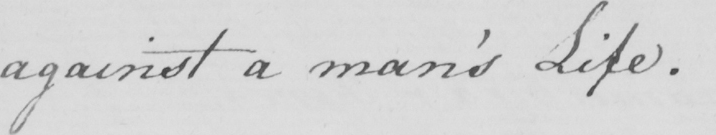What text is written in this handwritten line? against a man ' s Life . 